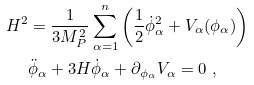<formula> <loc_0><loc_0><loc_500><loc_500>H ^ { 2 } & = \frac { 1 } { 3 M _ { P } ^ { 2 } } \sum _ { \alpha = 1 } ^ { n } \left ( \frac { 1 } { 2 } \dot { \phi } _ { \alpha } ^ { 2 } + V _ { \alpha } ( \phi _ { \alpha } ) \right ) \\ & \ddot { \phi } _ { \alpha } + 3 H \dot { \phi } _ { \alpha } + \partial _ { \phi _ { \alpha } } V _ { \alpha } = 0 \ ,</formula> 